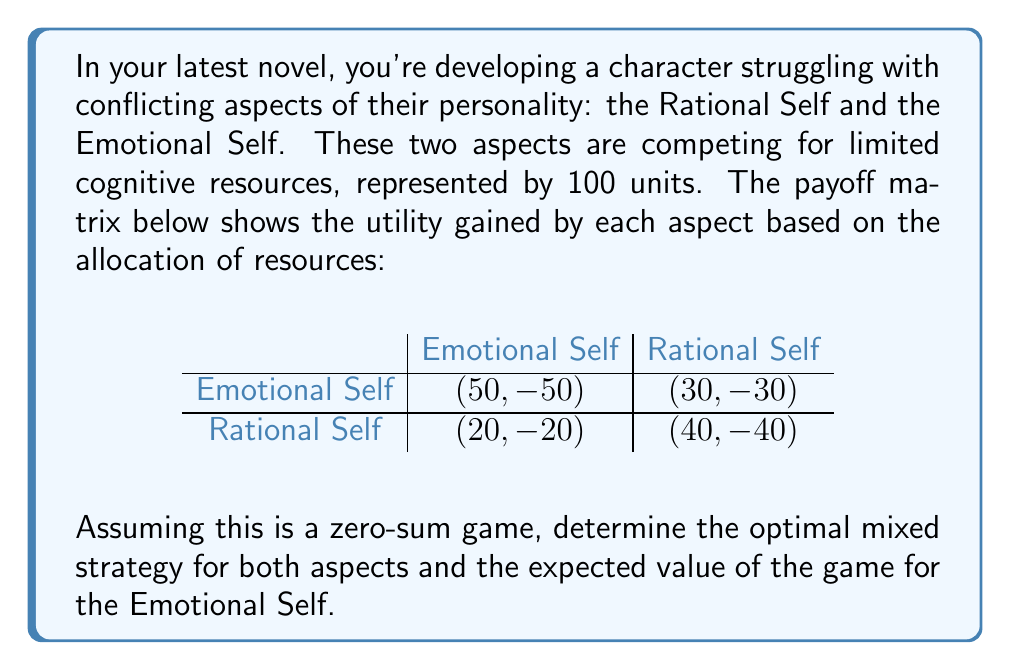Provide a solution to this math problem. To solve this problem, we'll use the minimax theorem for zero-sum games. Let's approach this step-by-step:

1) Let $p$ be the probability that the Emotional Self chooses the Emotional strategy, and $1-p$ the probability it chooses the Rational strategy.

2) Let $q$ be the probability that the Rational Self chooses the Emotional strategy, and $1-q$ the probability it chooses the Rational strategy.

3) The expected payoff for the Emotional Self is:

   $E = 50pq + 30p(1-q) + 20(1-p)q + 40(1-p)(1-q)$

4) To find the optimal strategy for the Emotional Self, we differentiate E with respect to p and set it to zero:

   $\frac{\partial E}{\partial p} = 50q + 30(1-q) - 20q - 40(1-q) = 0$
   $20q - 10 = 0$
   $q = \frac{1}{2}$

5) Similarly, for the Rational Self to be indifferent between its strategies:

   $50p + 20(1-p) = 30p + 40(1-p)$
   $30p = 20$
   $p = \frac{2}{3}$

6) Now we can calculate the value of the game by substituting these probabilities into the expected payoff equation:

   $E = 50(\frac{2}{3})(\frac{1}{2}) + 30(\frac{2}{3})(\frac{1}{2}) + 20(\frac{1}{3})(\frac{1}{2}) + 40(\frac{1}{3})(\frac{1}{2})$
   $= \frac{50}{3} + \frac{30}{3} + \frac{10}{3} + \frac{20}{3} = \frac{110}{3} \approx 36.67$

Therefore, the optimal mixed strategy for the Emotional Self is to choose the Emotional strategy with probability $\frac{2}{3}$ and the Rational strategy with probability $\frac{1}{3}$. The Rational Self should choose each strategy with probability $\frac{1}{2}$.
Answer: The optimal mixed strategy for the Emotional Self is $(\frac{2}{3}, \frac{1}{3})$, and for the Rational Self is $(\frac{1}{2}, \frac{1}{2})$. The expected value of the game for the Emotional Self is $\frac{110}{3} \approx 36.67$ units. 